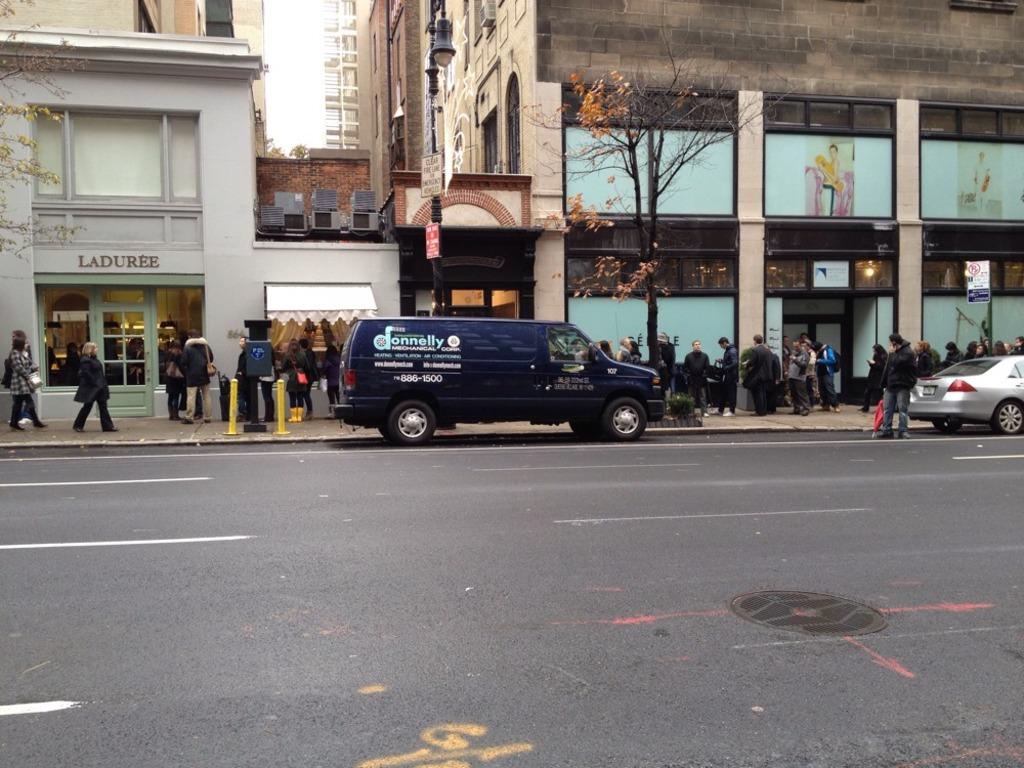What does the building on the left say on it in black letters?
Provide a succinct answer. Laduree. 